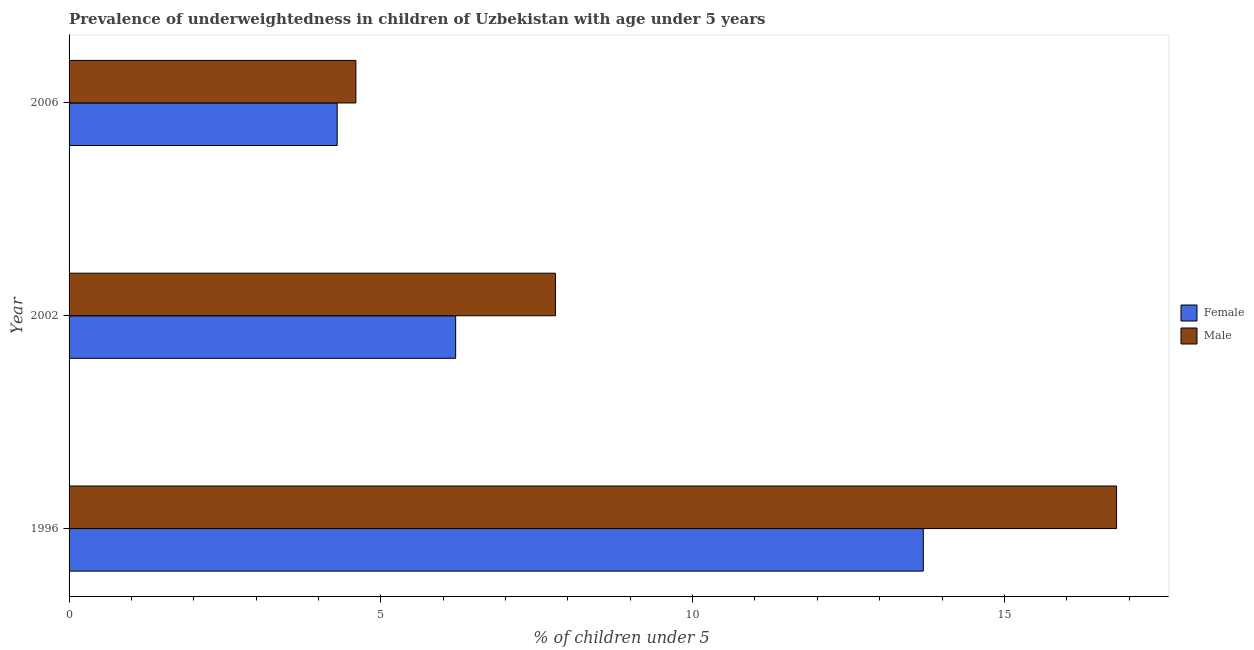How many different coloured bars are there?
Your answer should be compact. 2. How many groups of bars are there?
Your answer should be very brief. 3. Are the number of bars per tick equal to the number of legend labels?
Keep it short and to the point. Yes. Are the number of bars on each tick of the Y-axis equal?
Your answer should be very brief. Yes. How many bars are there on the 1st tick from the top?
Ensure brevity in your answer.  2. What is the label of the 1st group of bars from the top?
Offer a terse response. 2006. What is the percentage of underweighted female children in 1996?
Provide a short and direct response. 13.7. Across all years, what is the maximum percentage of underweighted female children?
Provide a short and direct response. 13.7. Across all years, what is the minimum percentage of underweighted male children?
Keep it short and to the point. 4.6. What is the total percentage of underweighted male children in the graph?
Ensure brevity in your answer.  29.2. What is the difference between the percentage of underweighted male children in 1996 and that in 2002?
Offer a very short reply. 9. What is the difference between the percentage of underweighted male children in 2002 and the percentage of underweighted female children in 1996?
Provide a succinct answer. -5.9. What is the average percentage of underweighted male children per year?
Ensure brevity in your answer.  9.73. In the year 2006, what is the difference between the percentage of underweighted female children and percentage of underweighted male children?
Ensure brevity in your answer.  -0.3. What is the ratio of the percentage of underweighted male children in 1996 to that in 2006?
Offer a very short reply. 3.65. Is the percentage of underweighted male children in 1996 less than that in 2002?
Ensure brevity in your answer.  No. Is the difference between the percentage of underweighted male children in 1996 and 2002 greater than the difference between the percentage of underweighted female children in 1996 and 2002?
Ensure brevity in your answer.  Yes. How many bars are there?
Make the answer very short. 6. Are all the bars in the graph horizontal?
Provide a succinct answer. Yes. How many years are there in the graph?
Give a very brief answer. 3. What is the difference between two consecutive major ticks on the X-axis?
Ensure brevity in your answer.  5. Are the values on the major ticks of X-axis written in scientific E-notation?
Offer a terse response. No. How are the legend labels stacked?
Your answer should be compact. Vertical. What is the title of the graph?
Keep it short and to the point. Prevalence of underweightedness in children of Uzbekistan with age under 5 years. What is the label or title of the X-axis?
Keep it short and to the point.  % of children under 5. What is the  % of children under 5 of Female in 1996?
Your response must be concise. 13.7. What is the  % of children under 5 in Male in 1996?
Your response must be concise. 16.8. What is the  % of children under 5 of Female in 2002?
Offer a terse response. 6.2. What is the  % of children under 5 of Male in 2002?
Make the answer very short. 7.8. What is the  % of children under 5 of Female in 2006?
Provide a short and direct response. 4.3. What is the  % of children under 5 of Male in 2006?
Ensure brevity in your answer.  4.6. Across all years, what is the maximum  % of children under 5 in Female?
Ensure brevity in your answer.  13.7. Across all years, what is the maximum  % of children under 5 in Male?
Provide a succinct answer. 16.8. Across all years, what is the minimum  % of children under 5 in Female?
Offer a terse response. 4.3. Across all years, what is the minimum  % of children under 5 in Male?
Provide a succinct answer. 4.6. What is the total  % of children under 5 in Female in the graph?
Your response must be concise. 24.2. What is the total  % of children under 5 in Male in the graph?
Provide a short and direct response. 29.2. What is the difference between the  % of children under 5 in Male in 1996 and that in 2002?
Provide a succinct answer. 9. What is the difference between the  % of children under 5 in Male in 1996 and that in 2006?
Make the answer very short. 12.2. What is the difference between the  % of children under 5 in Female in 2002 and that in 2006?
Ensure brevity in your answer.  1.9. What is the difference between the  % of children under 5 of Male in 2002 and that in 2006?
Offer a terse response. 3.2. What is the difference between the  % of children under 5 in Female in 1996 and the  % of children under 5 in Male in 2006?
Your answer should be compact. 9.1. What is the difference between the  % of children under 5 in Female in 2002 and the  % of children under 5 in Male in 2006?
Your response must be concise. 1.6. What is the average  % of children under 5 in Female per year?
Provide a succinct answer. 8.07. What is the average  % of children under 5 of Male per year?
Provide a short and direct response. 9.73. In the year 1996, what is the difference between the  % of children under 5 of Female and  % of children under 5 of Male?
Keep it short and to the point. -3.1. In the year 2002, what is the difference between the  % of children under 5 in Female and  % of children under 5 in Male?
Offer a very short reply. -1.6. What is the ratio of the  % of children under 5 of Female in 1996 to that in 2002?
Ensure brevity in your answer.  2.21. What is the ratio of the  % of children under 5 in Male in 1996 to that in 2002?
Offer a terse response. 2.15. What is the ratio of the  % of children under 5 in Female in 1996 to that in 2006?
Provide a short and direct response. 3.19. What is the ratio of the  % of children under 5 in Male in 1996 to that in 2006?
Make the answer very short. 3.65. What is the ratio of the  % of children under 5 in Female in 2002 to that in 2006?
Your answer should be compact. 1.44. What is the ratio of the  % of children under 5 of Male in 2002 to that in 2006?
Provide a short and direct response. 1.7. What is the difference between the highest and the second highest  % of children under 5 in Female?
Provide a succinct answer. 7.5. 